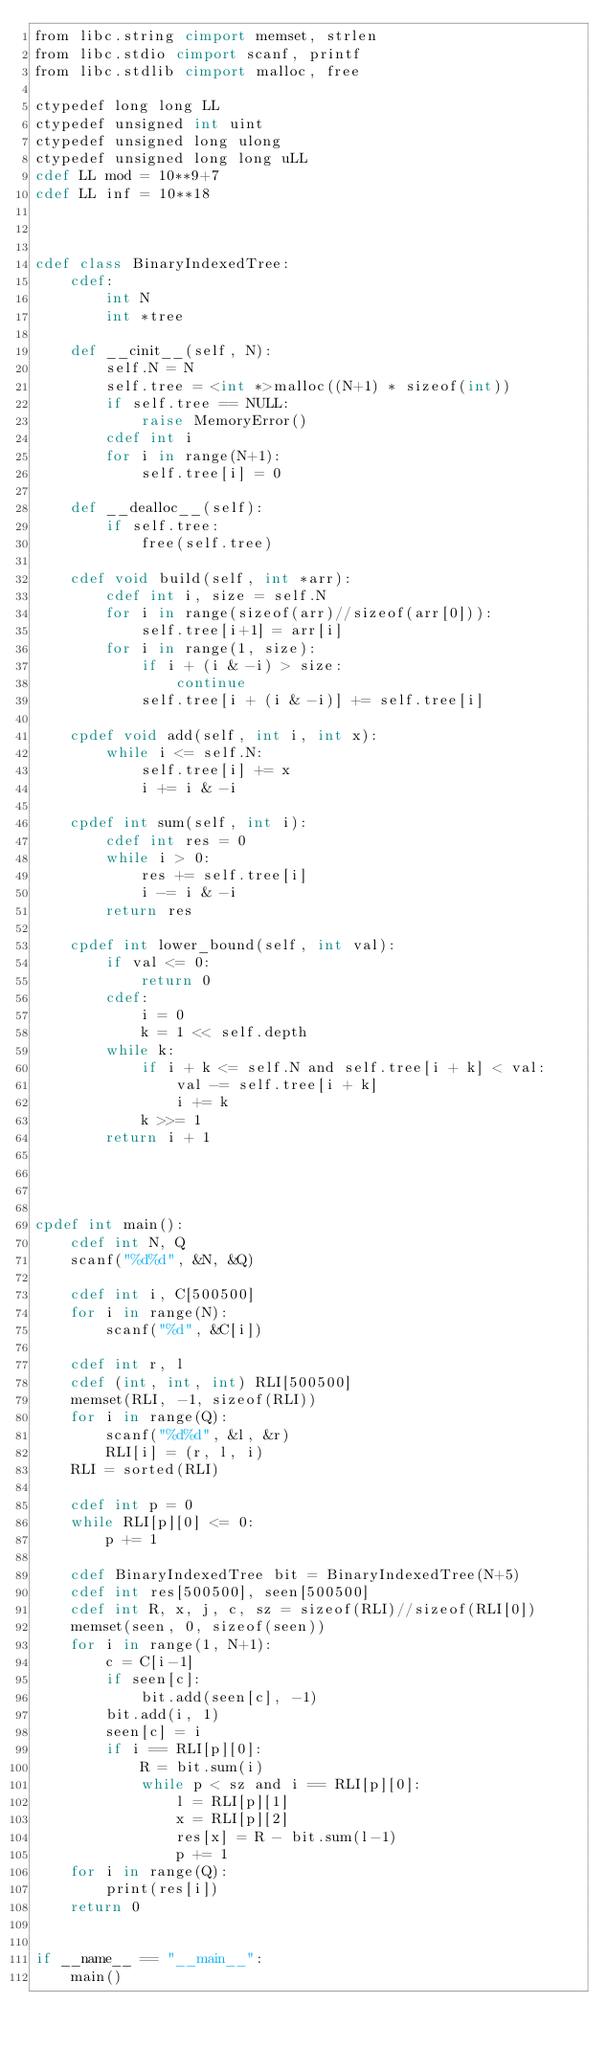<code> <loc_0><loc_0><loc_500><loc_500><_Cython_>from libc.string cimport memset, strlen
from libc.stdio cimport scanf, printf
from libc.stdlib cimport malloc, free

ctypedef long long LL
ctypedef unsigned int uint
ctypedef unsigned long ulong
ctypedef unsigned long long uLL
cdef LL mod = 10**9+7
cdef LL inf = 10**18



cdef class BinaryIndexedTree:
    cdef:
        int N
        int *tree
    
    def __cinit__(self, N):
        self.N = N
        self.tree = <int *>malloc((N+1) * sizeof(int))
        if self.tree == NULL:
            raise MemoryError()
        cdef int i
        for i in range(N+1):
            self.tree[i] = 0
    
    def __dealloc__(self):
        if self.tree:
            free(self.tree)
    
    cdef void build(self, int *arr):
        cdef int i, size = self.N
        for i in range(sizeof(arr)//sizeof(arr[0])):
            self.tree[i+1] = arr[i]
        for i in range(1, size):
            if i + (i & -i) > size:
                continue
            self.tree[i + (i & -i)] += self.tree[i]
            
    cpdef void add(self, int i, int x):
        while i <= self.N:
            self.tree[i] += x
            i += i & -i

    cpdef int sum(self, int i):
        cdef int res = 0
        while i > 0:
            res += self.tree[i]
            i -= i & -i
        return res

    cpdef int lower_bound(self, int val):
        if val <= 0:
            return 0
        cdef:
            i = 0
            k = 1 << self.depth
        while k:
            if i + k <= self.N and self.tree[i + k] < val:
                val -= self.tree[i + k]
                i += k
            k >>= 1
        return i + 1




cpdef int main():
    cdef int N, Q
    scanf("%d%d", &N, &Q)

    cdef int i, C[500500]
    for i in range(N):
        scanf("%d", &C[i])

    cdef int r, l
    cdef (int, int, int) RLI[500500]
    memset(RLI, -1, sizeof(RLI))
    for i in range(Q):
        scanf("%d%d", &l, &r)
        RLI[i] = (r, l, i)
    RLI = sorted(RLI)
    
    cdef int p = 0
    while RLI[p][0] <= 0:
        p += 1

    cdef BinaryIndexedTree bit = BinaryIndexedTree(N+5)
    cdef int res[500500], seen[500500]
    cdef int R, x, j, c, sz = sizeof(RLI)//sizeof(RLI[0])
    memset(seen, 0, sizeof(seen))
    for i in range(1, N+1):
        c = C[i-1]
        if seen[c]:
            bit.add(seen[c], -1)
        bit.add(i, 1)
        seen[c] = i
        if i == RLI[p][0]:
            R = bit.sum(i)
            while p < sz and i == RLI[p][0]:
                l = RLI[p][1]
                x = RLI[p][2]
                res[x] = R - bit.sum(l-1)
                p += 1
    for i in range(Q):
        print(res[i])
    return 0


if __name__ == "__main__":
    main()</code> 